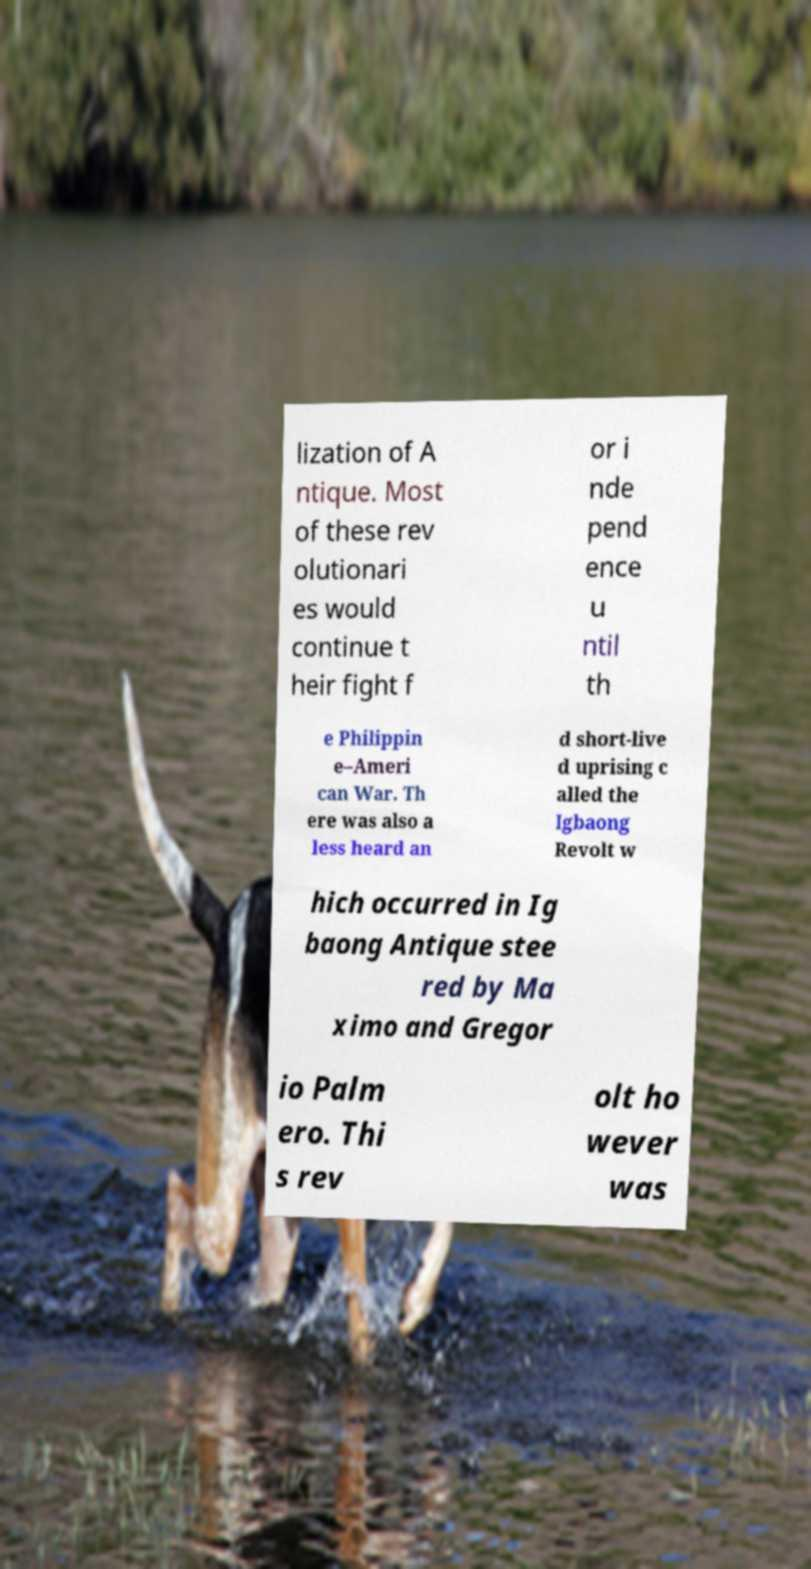Can you accurately transcribe the text from the provided image for me? lization of A ntique. Most of these rev olutionari es would continue t heir fight f or i nde pend ence u ntil th e Philippin e–Ameri can War. Th ere was also a less heard an d short-live d uprising c alled the Igbaong Revolt w hich occurred in Ig baong Antique stee red by Ma ximo and Gregor io Palm ero. Thi s rev olt ho wever was 